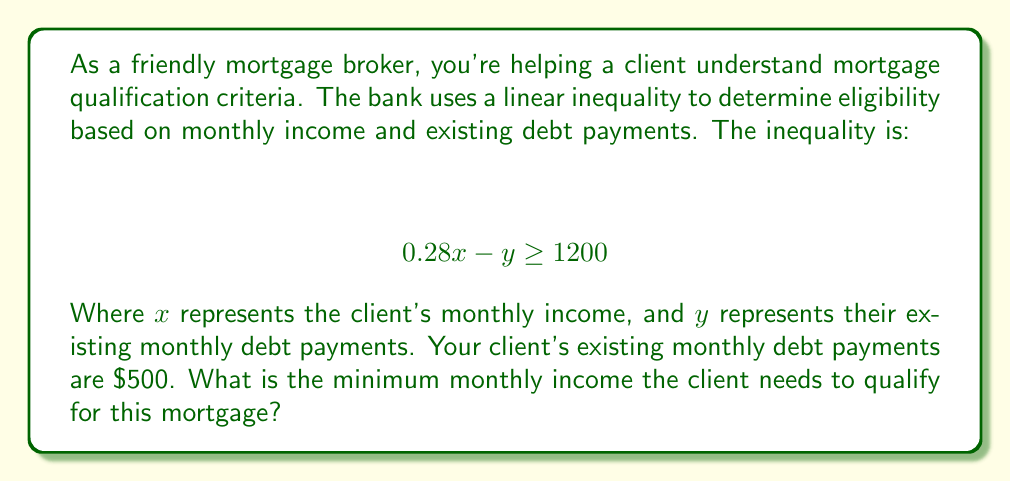Show me your answer to this math problem. Let's approach this step-by-step:

1) The inequality given is $0.28x - y \geq 1200$, where:
   $x$ = monthly income
   $y$ = existing monthly debt payments

2) We're told that the client's existing monthly debt payments ($y$) are $500.

3) Let's substitute this known value into the inequality:

   $$ 0.28x - 500 \geq 1200 $$

4) To solve for $x$, first add 500 to both sides:

   $$ 0.28x \geq 1700 $$

5) Now, divide both sides by 0.28:

   $$ x \geq \frac{1700}{0.28} $$

6) Calculating this:

   $$ x \geq 6071.43 $$

7) Since we're looking for the minimum monthly income, and income is typically rounded to whole dollars, we round up to the nearest dollar.

Therefore, the minimum monthly income needed is $6072.
Answer: $6072 